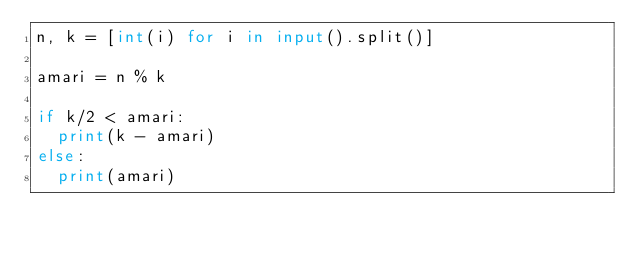<code> <loc_0><loc_0><loc_500><loc_500><_Python_>n, k = [int(i) for i in input().split()]

amari = n % k

if k/2 < amari:
  print(k - amari)
else:
  print(amari)</code> 